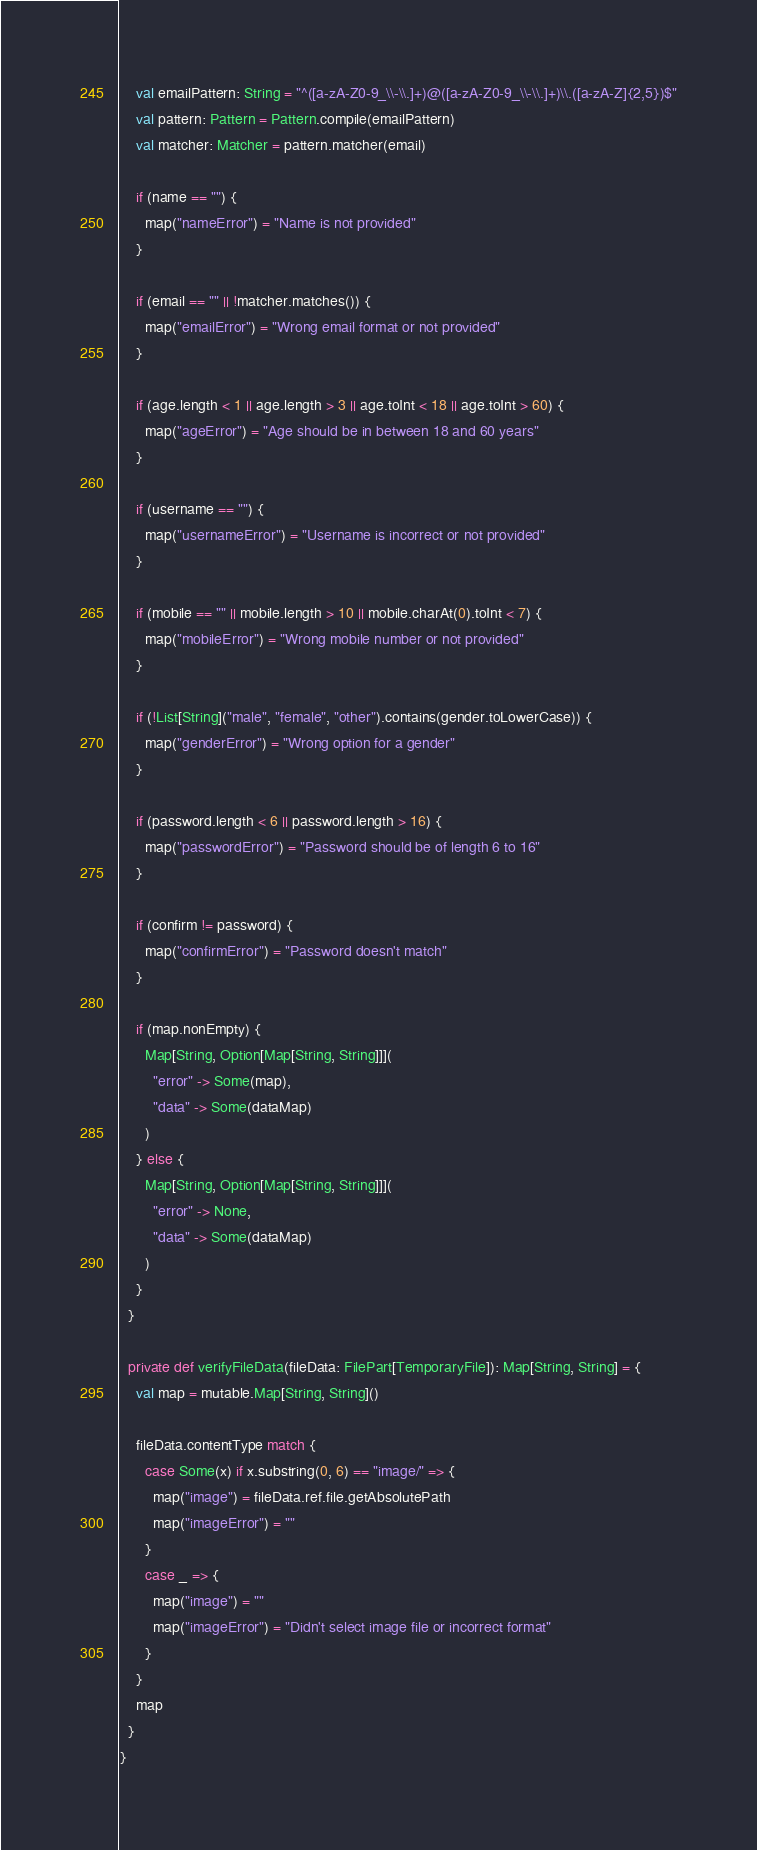<code> <loc_0><loc_0><loc_500><loc_500><_Scala_>    val emailPattern: String = "^([a-zA-Z0-9_\\-\\.]+)@([a-zA-Z0-9_\\-\\.]+)\\.([a-zA-Z]{2,5})$"
    val pattern: Pattern = Pattern.compile(emailPattern)
    val matcher: Matcher = pattern.matcher(email)

    if (name == "") {
      map("nameError") = "Name is not provided"
    }

    if (email == "" || !matcher.matches()) {
      map("emailError") = "Wrong email format or not provided"
    }

    if (age.length < 1 || age.length > 3 || age.toInt < 18 || age.toInt > 60) {
      map("ageError") = "Age should be in between 18 and 60 years"
    }

    if (username == "") {
      map("usernameError") = "Username is incorrect or not provided"
    }

    if (mobile == "" || mobile.length > 10 || mobile.charAt(0).toInt < 7) {
      map("mobileError") = "Wrong mobile number or not provided"
    }

    if (!List[String]("male", "female", "other").contains(gender.toLowerCase)) {
      map("genderError") = "Wrong option for a gender"
    }

    if (password.length < 6 || password.length > 16) {
      map("passwordError") = "Password should be of length 6 to 16"
    }

    if (confirm != password) {
      map("confirmError") = "Password doesn't match"
    }

    if (map.nonEmpty) {
      Map[String, Option[Map[String, String]]](
        "error" -> Some(map),
        "data" -> Some(dataMap)
      )
    } else {
      Map[String, Option[Map[String, String]]](
        "error" -> None,
        "data" -> Some(dataMap)
      )
    }
  }

  private def verifyFileData(fileData: FilePart[TemporaryFile]): Map[String, String] = {
    val map = mutable.Map[String, String]()

    fileData.contentType match {
      case Some(x) if x.substring(0, 6) == "image/" => {
        map("image") = fileData.ref.file.getAbsolutePath
        map("imageError") = ""
      }
      case _ => {
        map("image") = ""
        map("imageError") = "Didn't select image file or incorrect format"
      }
    }
    map
  }
}
</code> 